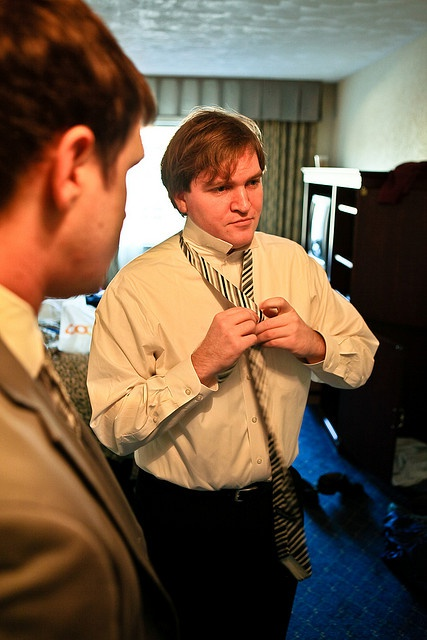Describe the objects in this image and their specific colors. I can see people in maroon, black, and tan tones, people in maroon, black, brown, and orange tones, tie in maroon, black, tan, and brown tones, tv in maroon, white, lightblue, black, and teal tones, and tie in maroon, brown, and tan tones in this image. 